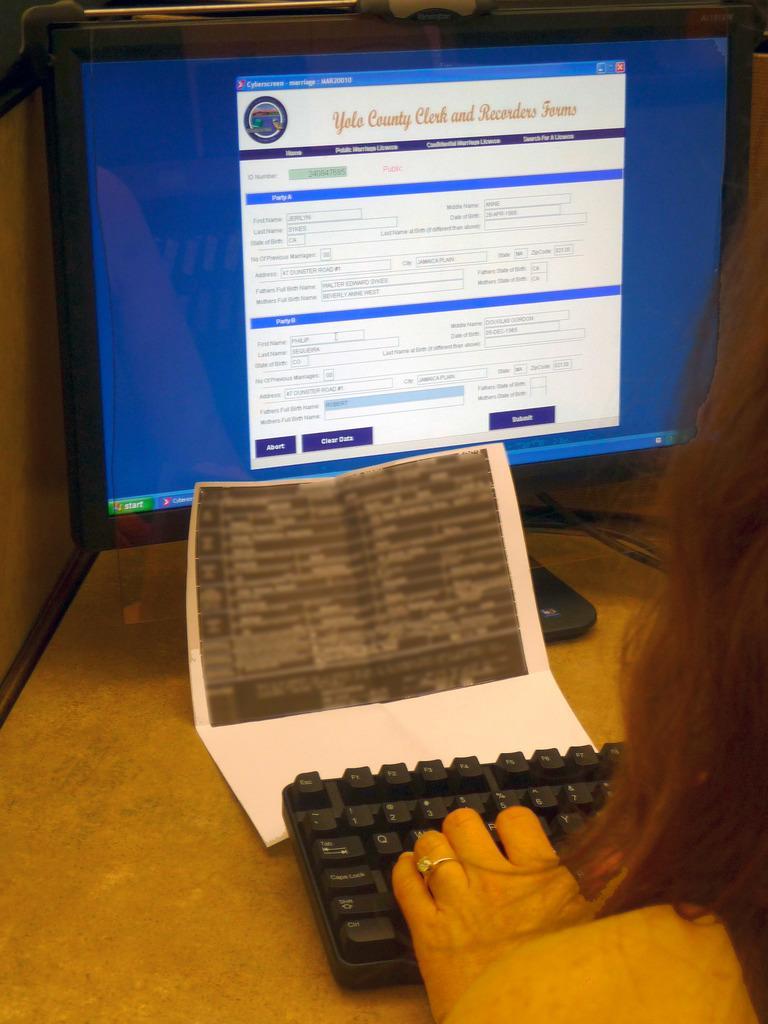In one or two sentences, can you explain what this image depicts? In this image we can see a person sitting in front of the desktop that is placed on the table. On the table we can also see a paper. 